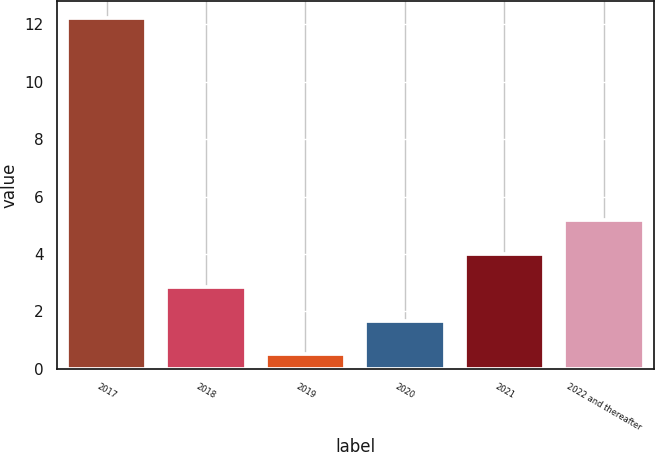<chart> <loc_0><loc_0><loc_500><loc_500><bar_chart><fcel>2017<fcel>2018<fcel>2019<fcel>2020<fcel>2021<fcel>2022 and thereafter<nl><fcel>12.2<fcel>2.84<fcel>0.5<fcel>1.67<fcel>4.01<fcel>5.18<nl></chart> 